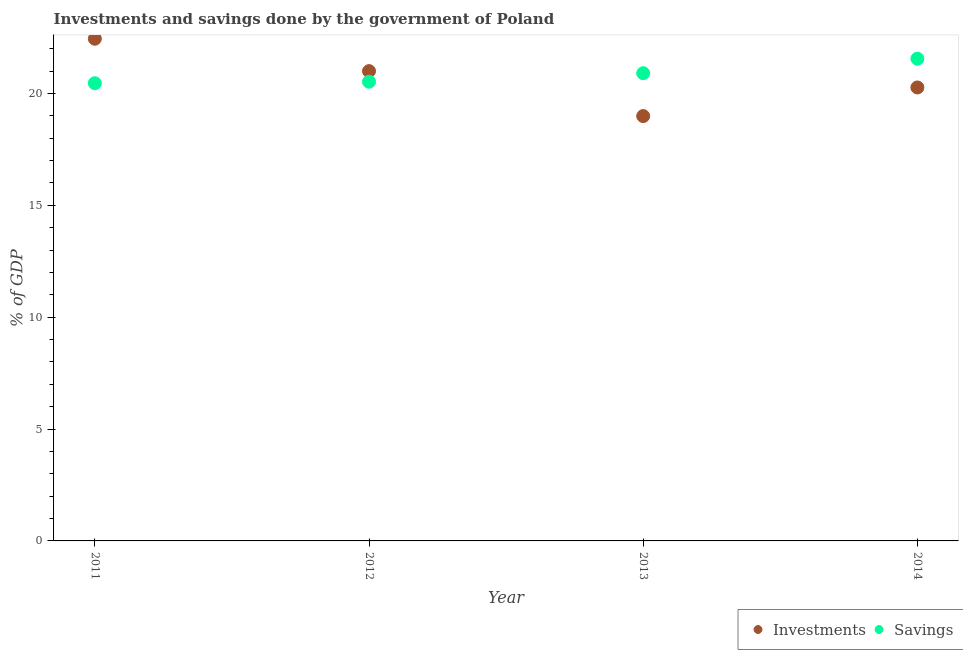What is the savings of government in 2013?
Your answer should be very brief. 20.9. Across all years, what is the maximum investments of government?
Your response must be concise. 22.44. Across all years, what is the minimum investments of government?
Your answer should be compact. 18.99. In which year was the investments of government maximum?
Provide a succinct answer. 2011. In which year was the savings of government minimum?
Offer a very short reply. 2011. What is the total savings of government in the graph?
Your answer should be compact. 83.43. What is the difference between the savings of government in 2011 and that in 2014?
Your response must be concise. -1.09. What is the difference between the investments of government in 2014 and the savings of government in 2012?
Your answer should be compact. -0.26. What is the average investments of government per year?
Your answer should be compact. 20.67. In the year 2012, what is the difference between the savings of government and investments of government?
Your answer should be compact. -0.47. In how many years, is the savings of government greater than 3 %?
Your response must be concise. 4. What is the ratio of the savings of government in 2012 to that in 2013?
Your response must be concise. 0.98. What is the difference between the highest and the second highest investments of government?
Offer a very short reply. 1.45. What is the difference between the highest and the lowest investments of government?
Keep it short and to the point. 3.46. Is the sum of the investments of government in 2013 and 2014 greater than the maximum savings of government across all years?
Your answer should be compact. Yes. Does the savings of government monotonically increase over the years?
Your answer should be very brief. Yes. Is the savings of government strictly less than the investments of government over the years?
Give a very brief answer. No. How many years are there in the graph?
Ensure brevity in your answer.  4. Are the values on the major ticks of Y-axis written in scientific E-notation?
Keep it short and to the point. No. Does the graph contain grids?
Provide a succinct answer. No. How many legend labels are there?
Provide a succinct answer. 2. What is the title of the graph?
Provide a short and direct response. Investments and savings done by the government of Poland. Does "Private funds" appear as one of the legend labels in the graph?
Give a very brief answer. No. What is the label or title of the Y-axis?
Provide a short and direct response. % of GDP. What is the % of GDP of Investments in 2011?
Give a very brief answer. 22.44. What is the % of GDP in Savings in 2011?
Give a very brief answer. 20.46. What is the % of GDP of Investments in 2012?
Offer a very short reply. 21. What is the % of GDP in Savings in 2012?
Make the answer very short. 20.52. What is the % of GDP of Investments in 2013?
Provide a short and direct response. 18.99. What is the % of GDP of Savings in 2013?
Keep it short and to the point. 20.9. What is the % of GDP in Investments in 2014?
Keep it short and to the point. 20.27. What is the % of GDP in Savings in 2014?
Your answer should be very brief. 21.55. Across all years, what is the maximum % of GDP of Investments?
Your answer should be compact. 22.44. Across all years, what is the maximum % of GDP of Savings?
Provide a short and direct response. 21.55. Across all years, what is the minimum % of GDP of Investments?
Your response must be concise. 18.99. Across all years, what is the minimum % of GDP in Savings?
Ensure brevity in your answer.  20.46. What is the total % of GDP in Investments in the graph?
Provide a short and direct response. 82.69. What is the total % of GDP of Savings in the graph?
Your answer should be very brief. 83.43. What is the difference between the % of GDP of Investments in 2011 and that in 2012?
Ensure brevity in your answer.  1.45. What is the difference between the % of GDP in Savings in 2011 and that in 2012?
Ensure brevity in your answer.  -0.07. What is the difference between the % of GDP of Investments in 2011 and that in 2013?
Provide a short and direct response. 3.46. What is the difference between the % of GDP in Savings in 2011 and that in 2013?
Give a very brief answer. -0.45. What is the difference between the % of GDP of Investments in 2011 and that in 2014?
Make the answer very short. 2.18. What is the difference between the % of GDP in Savings in 2011 and that in 2014?
Your response must be concise. -1.09. What is the difference between the % of GDP in Investments in 2012 and that in 2013?
Make the answer very short. 2.01. What is the difference between the % of GDP in Savings in 2012 and that in 2013?
Your answer should be compact. -0.38. What is the difference between the % of GDP in Investments in 2012 and that in 2014?
Provide a succinct answer. 0.73. What is the difference between the % of GDP in Savings in 2012 and that in 2014?
Give a very brief answer. -1.03. What is the difference between the % of GDP of Investments in 2013 and that in 2014?
Provide a short and direct response. -1.28. What is the difference between the % of GDP in Savings in 2013 and that in 2014?
Provide a short and direct response. -0.65. What is the difference between the % of GDP of Investments in 2011 and the % of GDP of Savings in 2012?
Provide a short and direct response. 1.92. What is the difference between the % of GDP of Investments in 2011 and the % of GDP of Savings in 2013?
Your answer should be very brief. 1.54. What is the difference between the % of GDP in Investments in 2011 and the % of GDP in Savings in 2014?
Give a very brief answer. 0.89. What is the difference between the % of GDP in Investments in 2012 and the % of GDP in Savings in 2013?
Ensure brevity in your answer.  0.09. What is the difference between the % of GDP of Investments in 2012 and the % of GDP of Savings in 2014?
Your response must be concise. -0.55. What is the difference between the % of GDP of Investments in 2013 and the % of GDP of Savings in 2014?
Provide a succinct answer. -2.56. What is the average % of GDP in Investments per year?
Your answer should be compact. 20.67. What is the average % of GDP in Savings per year?
Keep it short and to the point. 20.86. In the year 2011, what is the difference between the % of GDP of Investments and % of GDP of Savings?
Your answer should be compact. 1.99. In the year 2012, what is the difference between the % of GDP of Investments and % of GDP of Savings?
Your answer should be compact. 0.47. In the year 2013, what is the difference between the % of GDP in Investments and % of GDP in Savings?
Make the answer very short. -1.92. In the year 2014, what is the difference between the % of GDP of Investments and % of GDP of Savings?
Provide a short and direct response. -1.28. What is the ratio of the % of GDP in Investments in 2011 to that in 2012?
Provide a succinct answer. 1.07. What is the ratio of the % of GDP of Savings in 2011 to that in 2012?
Your answer should be very brief. 1. What is the ratio of the % of GDP in Investments in 2011 to that in 2013?
Your answer should be very brief. 1.18. What is the ratio of the % of GDP of Savings in 2011 to that in 2013?
Keep it short and to the point. 0.98. What is the ratio of the % of GDP of Investments in 2011 to that in 2014?
Keep it short and to the point. 1.11. What is the ratio of the % of GDP in Savings in 2011 to that in 2014?
Provide a succinct answer. 0.95. What is the ratio of the % of GDP of Investments in 2012 to that in 2013?
Your answer should be compact. 1.11. What is the ratio of the % of GDP of Savings in 2012 to that in 2013?
Ensure brevity in your answer.  0.98. What is the ratio of the % of GDP of Investments in 2012 to that in 2014?
Provide a short and direct response. 1.04. What is the ratio of the % of GDP in Savings in 2012 to that in 2014?
Your answer should be very brief. 0.95. What is the ratio of the % of GDP in Investments in 2013 to that in 2014?
Provide a short and direct response. 0.94. What is the difference between the highest and the second highest % of GDP in Investments?
Provide a succinct answer. 1.45. What is the difference between the highest and the second highest % of GDP in Savings?
Keep it short and to the point. 0.65. What is the difference between the highest and the lowest % of GDP in Investments?
Provide a short and direct response. 3.46. What is the difference between the highest and the lowest % of GDP of Savings?
Provide a short and direct response. 1.09. 